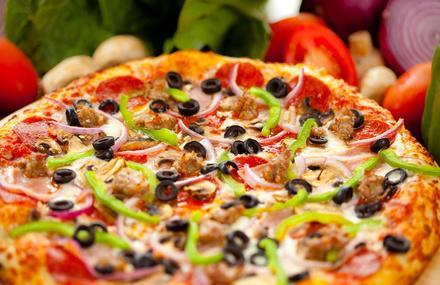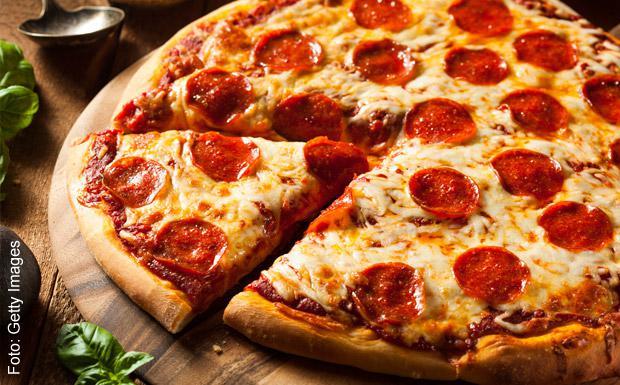The first image is the image on the left, the second image is the image on the right. For the images shown, is this caption "Someone is using a pizza server tool to help themselves to a slice of pizza in at least one of the pictures." true? Answer yes or no. No. The first image is the image on the left, the second image is the image on the right. Assess this claim about the two images: "An image shows a single slice of pizza lifted upward, with cheese stretching all along the side.". Correct or not? Answer yes or no. No. 